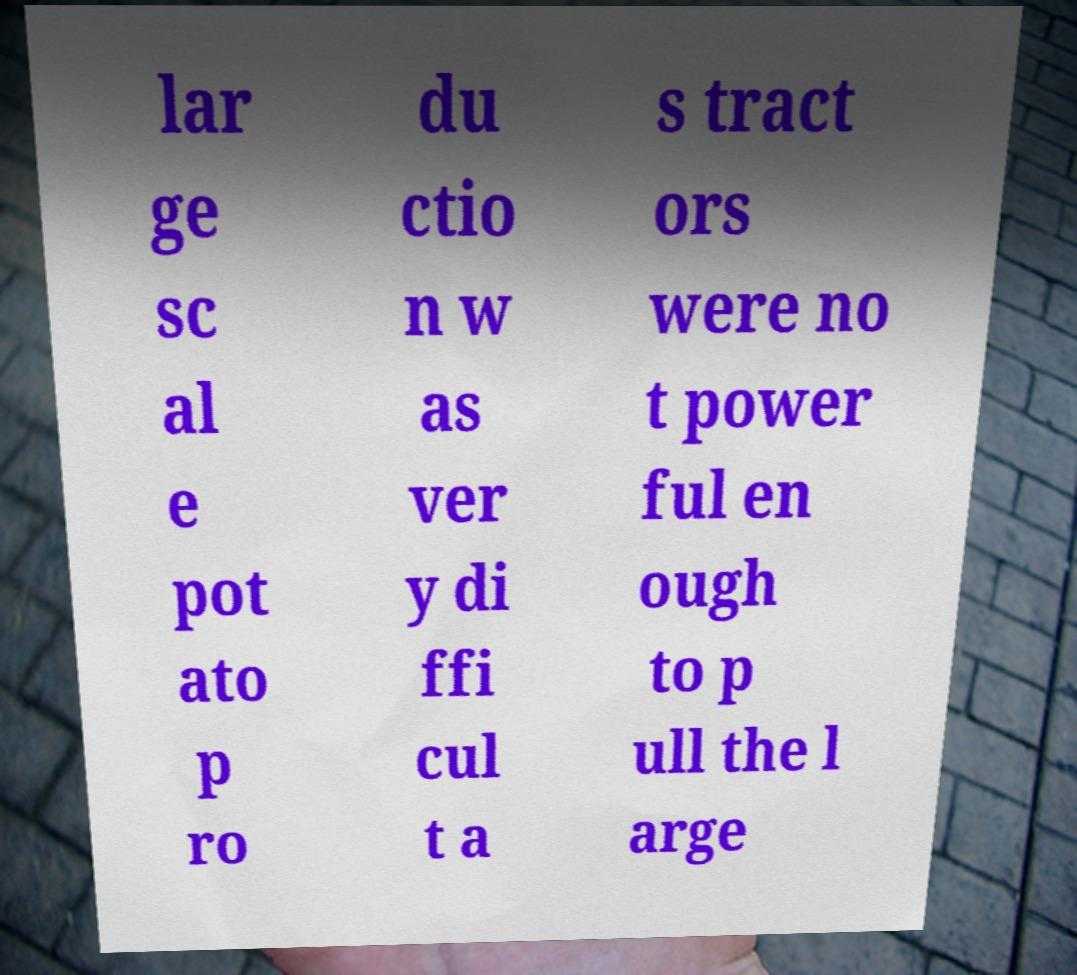Could you extract and type out the text from this image? lar ge sc al e pot ato p ro du ctio n w as ver y di ffi cul t a s tract ors were no t power ful en ough to p ull the l arge 